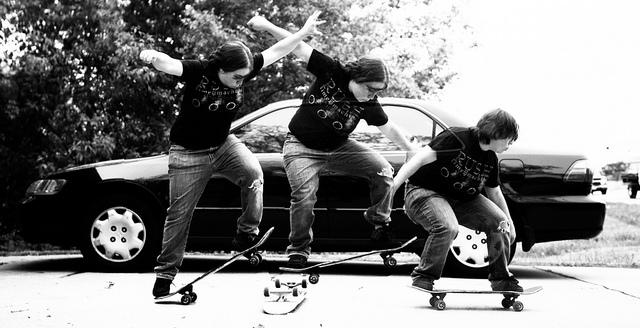How many skateboards are in the picture?
Be succinct. 3. Is this a picture of triplets?
Quick response, please. No. Is this picture edited?
Keep it brief. Yes. 